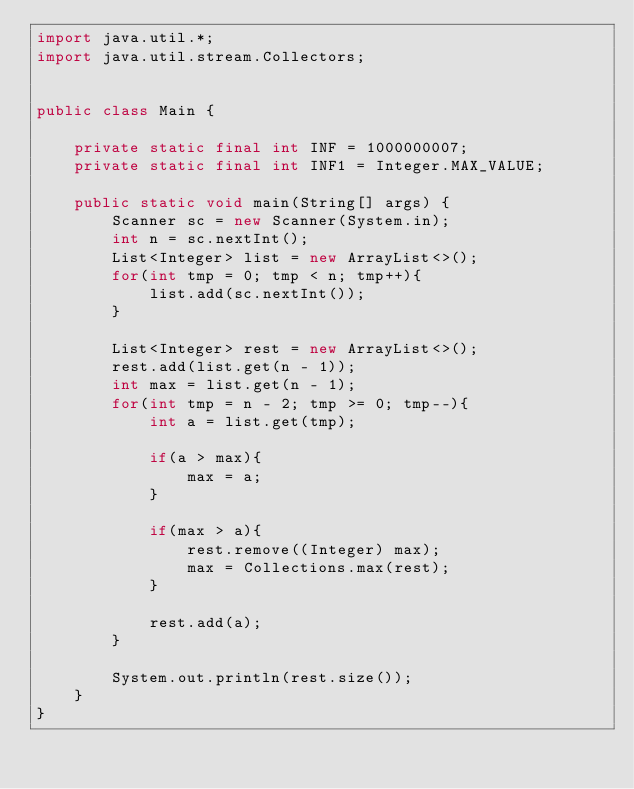Convert code to text. <code><loc_0><loc_0><loc_500><loc_500><_Java_>import java.util.*;
import java.util.stream.Collectors;


public class Main {

    private static final int INF = 1000000007;
    private static final int INF1 = Integer.MAX_VALUE;

    public static void main(String[] args) {
        Scanner sc = new Scanner(System.in);
        int n = sc.nextInt();
        List<Integer> list = new ArrayList<>();
        for(int tmp = 0; tmp < n; tmp++){
            list.add(sc.nextInt());
        }

        List<Integer> rest = new ArrayList<>();
        rest.add(list.get(n - 1));
        int max = list.get(n - 1);
        for(int tmp = n - 2; tmp >= 0; tmp--){
            int a = list.get(tmp);

            if(a > max){
                max = a;
            }

            if(max > a){
                rest.remove((Integer) max);
                max = Collections.max(rest);
            }

            rest.add(a);
        }

        System.out.println(rest.size());
    }
}
</code> 